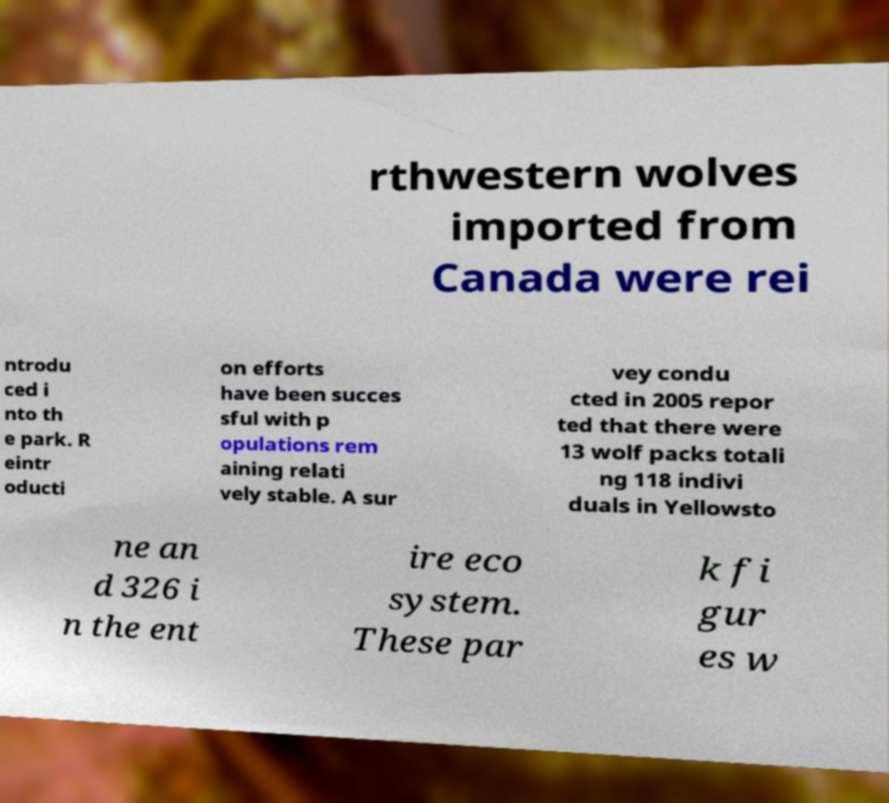Please identify and transcribe the text found in this image. rthwestern wolves imported from Canada were rei ntrodu ced i nto th e park. R eintr oducti on efforts have been succes sful with p opulations rem aining relati vely stable. A sur vey condu cted in 2005 repor ted that there were 13 wolf packs totali ng 118 indivi duals in Yellowsto ne an d 326 i n the ent ire eco system. These par k fi gur es w 